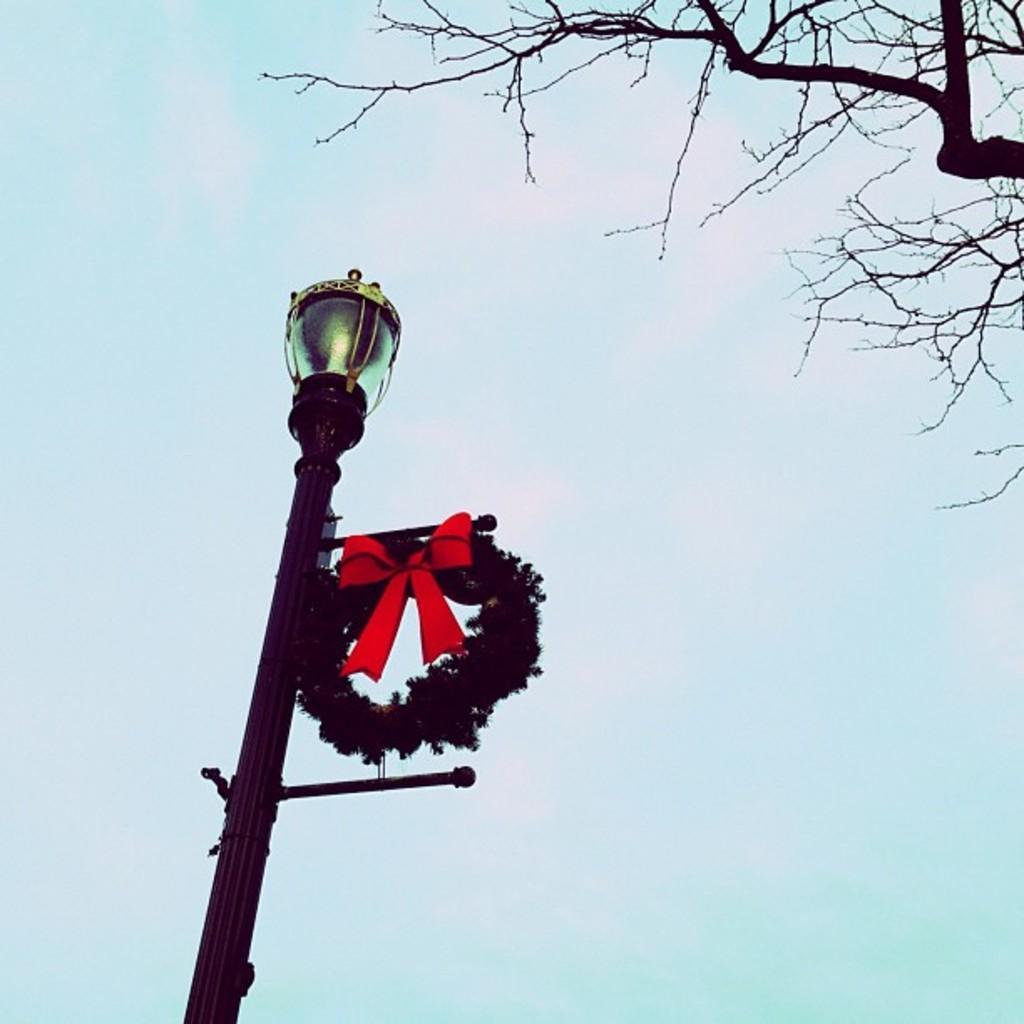In one or two sentences, can you explain what this image depicts? On the left side of this image I can see a pole. At the top of it I can see a light. On the top of the image I can see a tree and the sky. 